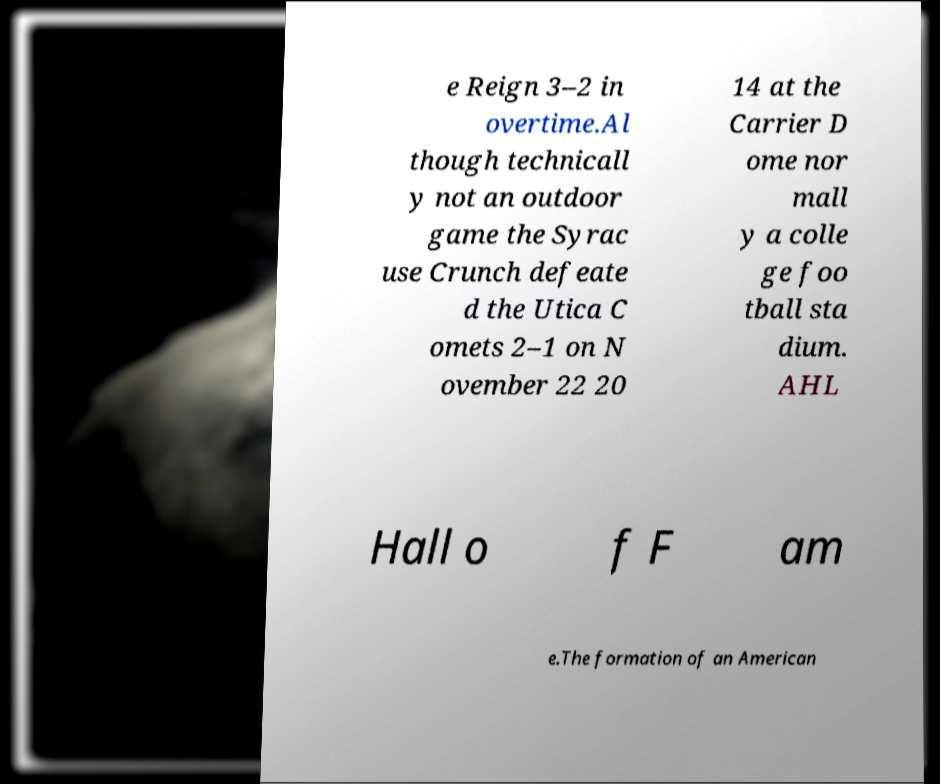I need the written content from this picture converted into text. Can you do that? e Reign 3–2 in overtime.Al though technicall y not an outdoor game the Syrac use Crunch defeate d the Utica C omets 2–1 on N ovember 22 20 14 at the Carrier D ome nor mall y a colle ge foo tball sta dium. AHL Hall o f F am e.The formation of an American 